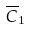<formula> <loc_0><loc_0><loc_500><loc_500>\overline { C } _ { 1 }</formula> 